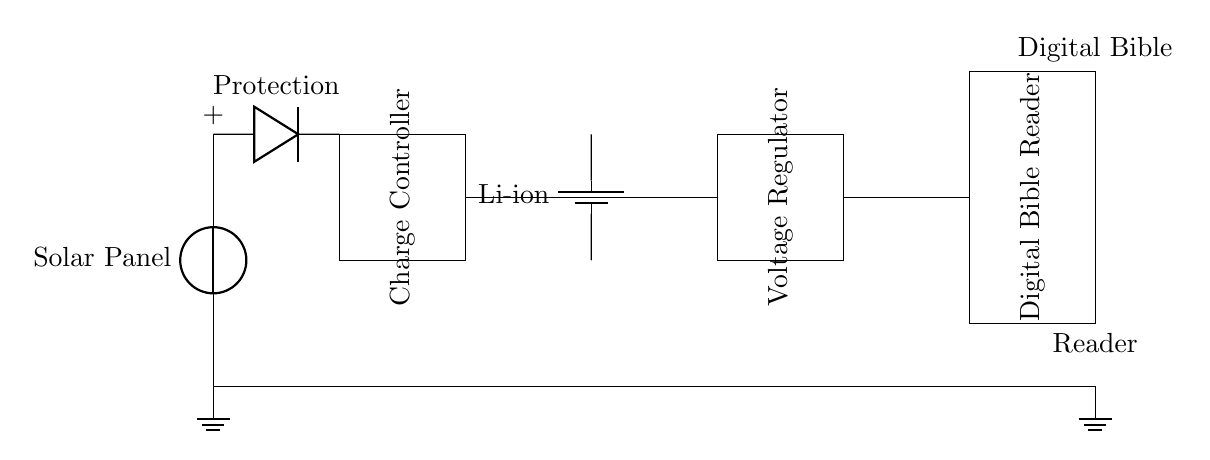What component is used for protection in the circuit? The protection component in the circuit is a diode, which is typically used to prevent reverse current flow and protect the rest of the circuit.
Answer: Diode What type of battery is used in this circuit? The circuit specifies a lithium-ion battery, which is commonly used for its efficient energy storage and discharge characteristics.
Answer: Li-ion How many main components are there in this circuit? The circuit diagram includes five main components: a solar panel, a diode, a charge controller, a battery, and a voltage regulator, along with the digital Bible reader.
Answer: Five What is the purpose of the voltage regulator in this circuit? The voltage regulator's role is to ensure that the output voltage remains stable and within the required limits for the digital Bible reader, protecting it from voltage fluctuations.
Answer: Stabilize voltage How is the solar panel connected to the rest of the circuit? The solar panel is connected to the circuit, sending electrical energy through a diode to the charge controller, which manages the charge to the battery.
Answer: Diode to charge controller What does the charge controller do in this circuit? The charge controller regulates the energy coming from the solar panel to safely charge the lithium-ion battery while preventing overcharging, thereby prolonging the battery's lifespan.
Answer: Manage charging 